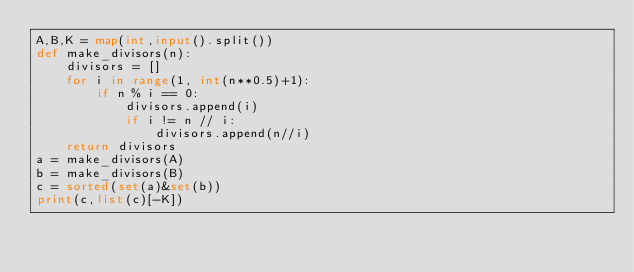<code> <loc_0><loc_0><loc_500><loc_500><_Python_>A,B,K = map(int,input().split())
def make_divisors(n):
    divisors = []
    for i in range(1, int(n**0.5)+1):
        if n % i == 0:
            divisors.append(i)
            if i != n // i:
                divisors.append(n//i)
    return divisors
a = make_divisors(A)
b = make_divisors(B)
c = sorted(set(a)&set(b))
print(c,list(c)[-K])</code> 